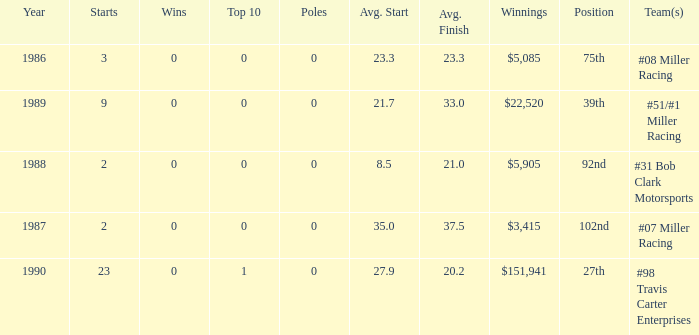What are the racing teams for which the average finish is 23.3? #08 Miller Racing. 